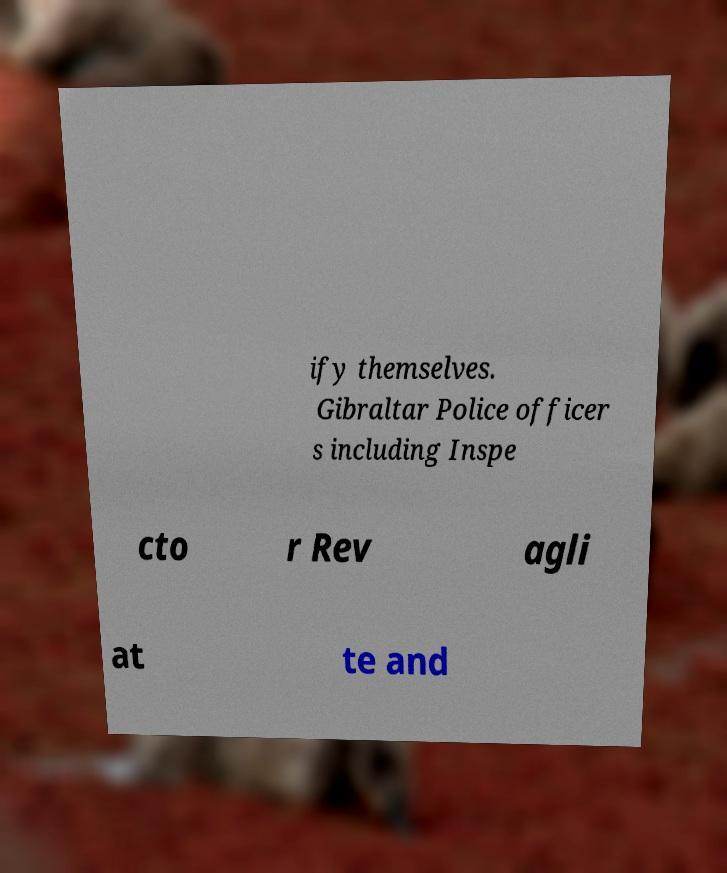What messages or text are displayed in this image? I need them in a readable, typed format. ify themselves. Gibraltar Police officer s including Inspe cto r Rev agli at te and 